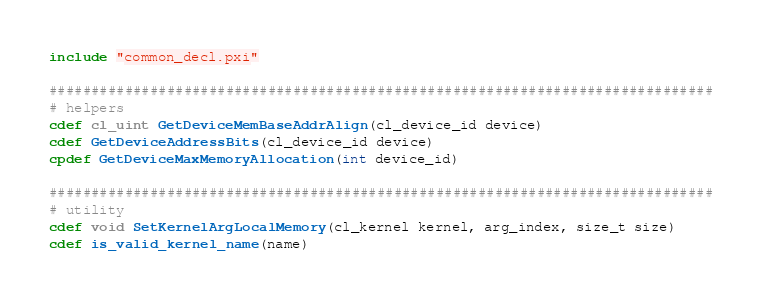Convert code to text. <code><loc_0><loc_0><loc_500><loc_500><_Cython_>include "common_decl.pxi"

###############################################################################
# helpers
cdef cl_uint GetDeviceMemBaseAddrAlign(cl_device_id device)
cdef GetDeviceAddressBits(cl_device_id device)
cpdef GetDeviceMaxMemoryAllocation(int device_id)

###############################################################################
# utility
cdef void SetKernelArgLocalMemory(cl_kernel kernel, arg_index, size_t size)
cdef is_valid_kernel_name(name)</code> 